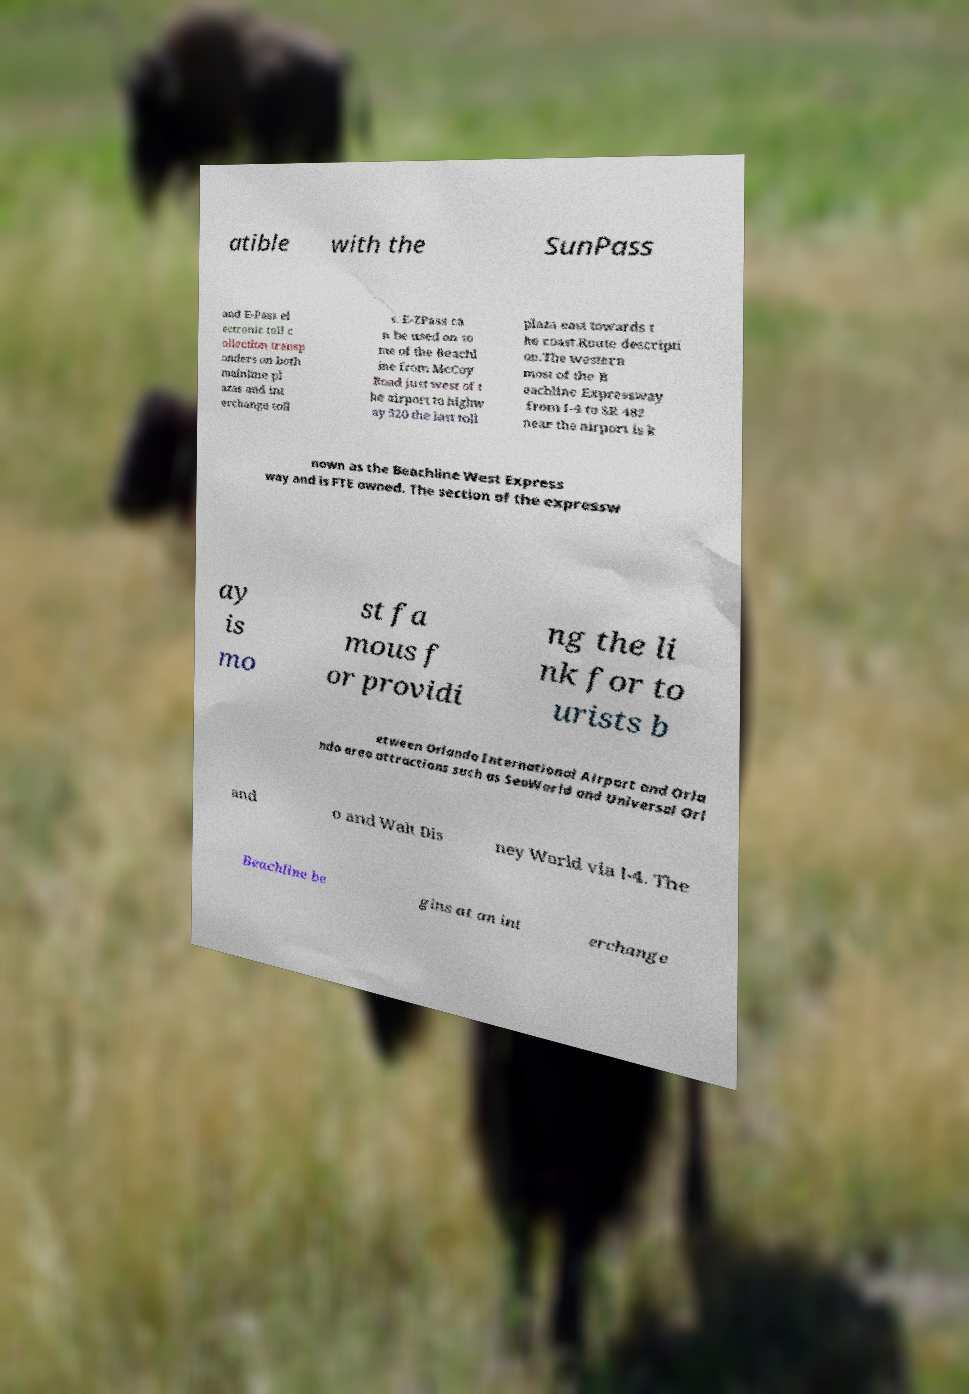There's text embedded in this image that I need extracted. Can you transcribe it verbatim? atible with the SunPass and E-Pass el ectronic toll c ollection transp onders on both mainline pl azas and int erchange toll s. E-ZPass ca n be used on so me of the Beachl ine from McCoy Road just west of t he airport to highw ay 520 the last toll plaza east towards t he coast.Route descripti on.The western most of the B eachline Expressway from I-4 to SR 482 near the airport is k nown as the Beachline West Express way and is FTE owned. The section of the expressw ay is mo st fa mous f or providi ng the li nk for to urists b etween Orlando International Airport and Orla ndo area attractions such as SeaWorld and Universal Orl and o and Walt Dis ney World via I-4. The Beachline be gins at an int erchange 